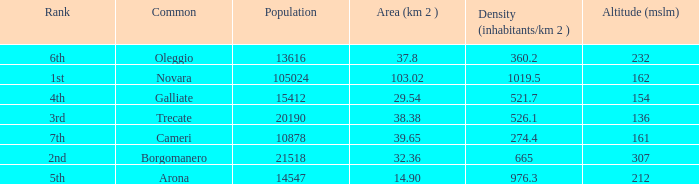Which common has an area (km2) of 103.02? Novara. 